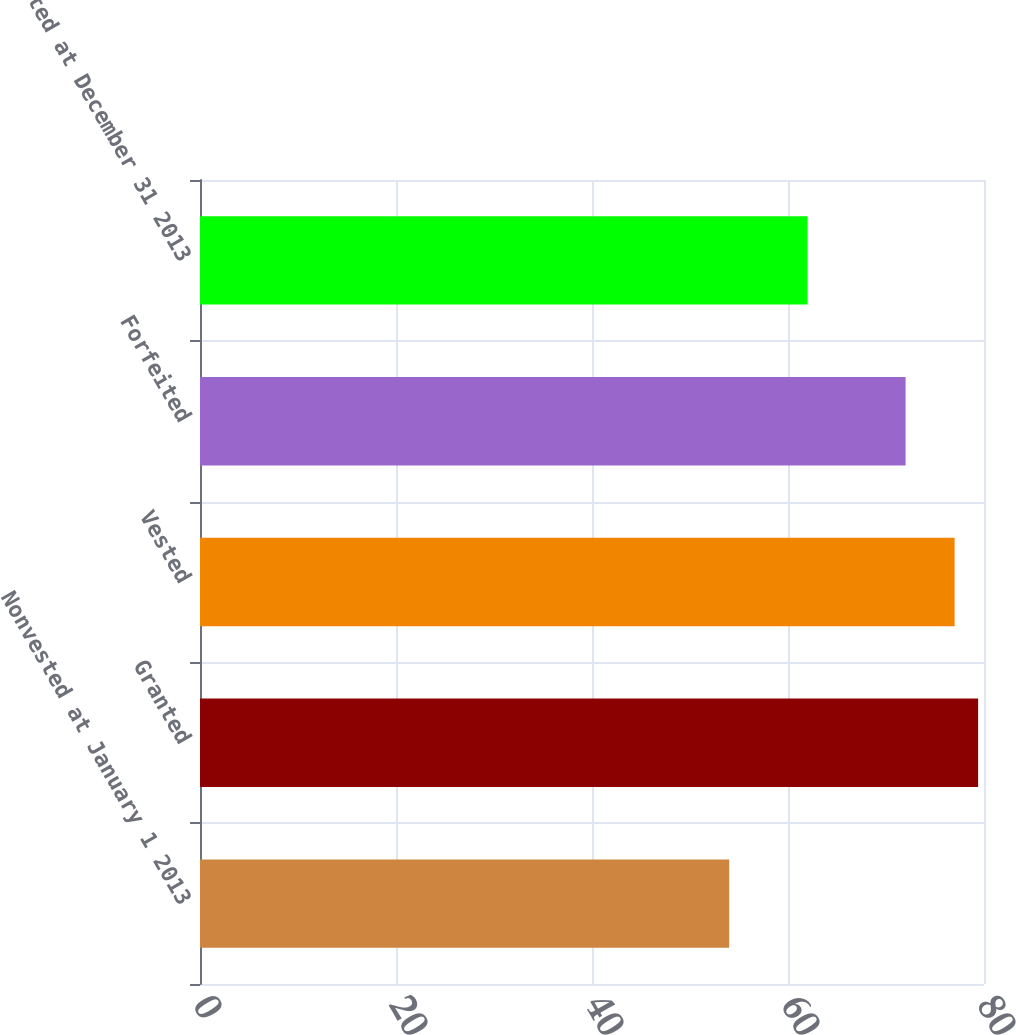Convert chart. <chart><loc_0><loc_0><loc_500><loc_500><bar_chart><fcel>Nonvested at January 1 2013<fcel>Granted<fcel>Vested<fcel>Forfeited<fcel>Nonvested at December 31 2013<nl><fcel>54<fcel>79.4<fcel>77<fcel>72<fcel>62<nl></chart> 